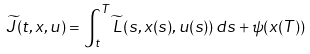Convert formula to latex. <formula><loc_0><loc_0><loc_500><loc_500>\widetilde { J } ( t , x , u ) = \int _ { t } ^ { T } \widetilde { L } \left ( s , x ( s ) , u ( s ) \right ) d s + \psi ( x ( T ) )</formula> 